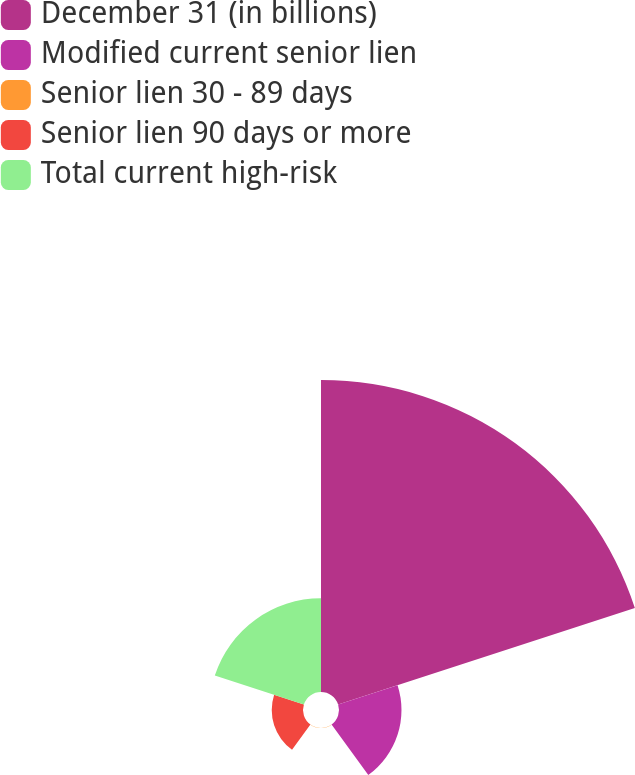<chart> <loc_0><loc_0><loc_500><loc_500><pie_chart><fcel>December 31 (in billions)<fcel>Modified current senior lien<fcel>Senior lien 30 - 89 days<fcel>Senior lien 90 days or more<fcel>Total current high-risk<nl><fcel>62.47%<fcel>12.51%<fcel>0.02%<fcel>6.26%<fcel>18.75%<nl></chart> 